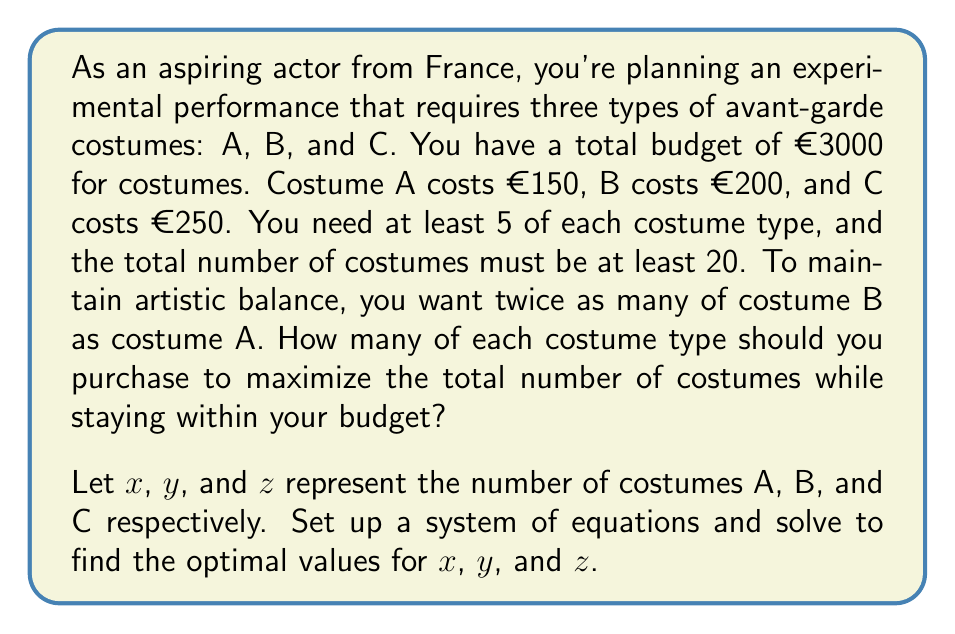Provide a solution to this math problem. Let's approach this step-by-step:

1) First, we can set up our system of equations based on the given information:

   Budget constraint: $150x + 200y + 250z \leq 3000$
   Minimum total costumes: $x + y + z \geq 20$
   Artistic balance: $y = 2x$
   Minimum of each type: $x \geq 5$, $y \geq 5$, $z \geq 5$

2) Substituting $y = 2x$ into the budget constraint:
   $150x + 200(2x) + 250z \leq 3000$
   $150x + 400x + 250z \leq 3000$
   $550x + 250z \leq 3000$

3) Our objective is to maximize $x + y + z$, which is equivalent to maximizing $x + 2x + z = 3x + z$

4) We can solve this using the corner point method. The feasible region is bounded by:
   $550x + 250z = 3000$
   $x = 5$
   $z = 5$
   $3x + z = 20$

5) The corner points are:
   (5, 10, 5) - satisfies minimum requirements
   (5, 10, 7) - intersection of $x = 5$ and $550x + 250z = 3000$
   (4, 8, 8) - intersection of $550x + 250z = 3000$ and $3x + z = 20$

6) Evaluating $3x + z$ at these points:
   (5, 10, 5): $3(5) + 5 = 20$
   (5, 10, 7): $3(5) + 7 = 22$
   (4, 8, 8): $3(4) + 8 = 20$

7) The maximum value is achieved at (5, 10, 7)

Therefore, the optimal solution is to purchase 5 of costume A, 10 of costume B, and 7 of costume C.
Answer: Costume A: 5, Costume B: 10, Costume C: 7 